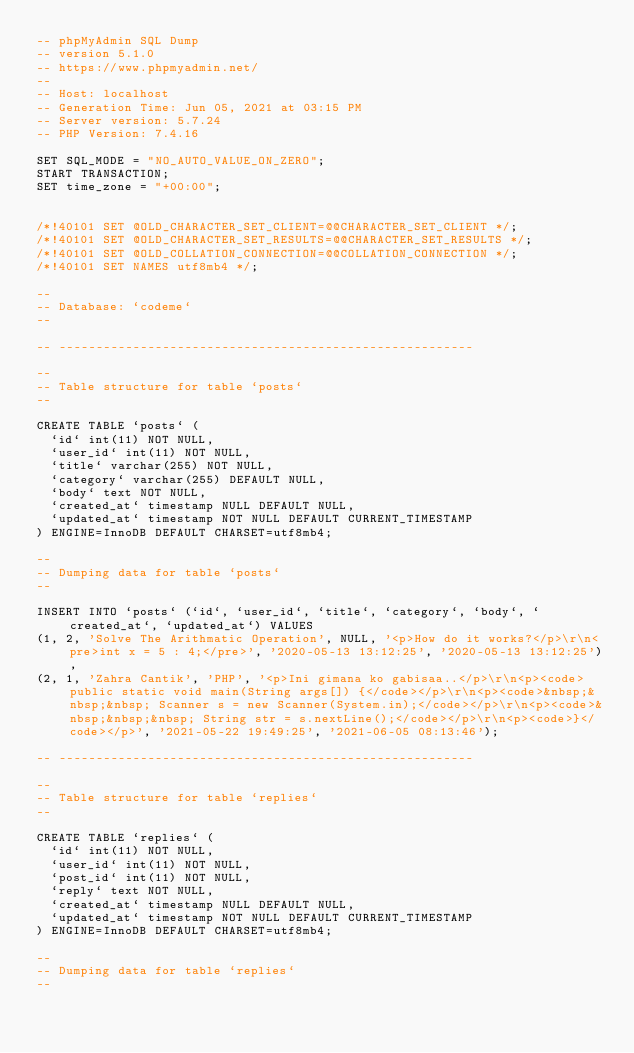<code> <loc_0><loc_0><loc_500><loc_500><_SQL_>-- phpMyAdmin SQL Dump
-- version 5.1.0
-- https://www.phpmyadmin.net/
--
-- Host: localhost
-- Generation Time: Jun 05, 2021 at 03:15 PM
-- Server version: 5.7.24
-- PHP Version: 7.4.16

SET SQL_MODE = "NO_AUTO_VALUE_ON_ZERO";
START TRANSACTION;
SET time_zone = "+00:00";


/*!40101 SET @OLD_CHARACTER_SET_CLIENT=@@CHARACTER_SET_CLIENT */;
/*!40101 SET @OLD_CHARACTER_SET_RESULTS=@@CHARACTER_SET_RESULTS */;
/*!40101 SET @OLD_COLLATION_CONNECTION=@@COLLATION_CONNECTION */;
/*!40101 SET NAMES utf8mb4 */;

--
-- Database: `codeme`
--

-- --------------------------------------------------------

--
-- Table structure for table `posts`
--

CREATE TABLE `posts` (
  `id` int(11) NOT NULL,
  `user_id` int(11) NOT NULL,
  `title` varchar(255) NOT NULL,
  `category` varchar(255) DEFAULT NULL,
  `body` text NOT NULL,
  `created_at` timestamp NULL DEFAULT NULL,
  `updated_at` timestamp NOT NULL DEFAULT CURRENT_TIMESTAMP
) ENGINE=InnoDB DEFAULT CHARSET=utf8mb4;

--
-- Dumping data for table `posts`
--

INSERT INTO `posts` (`id`, `user_id`, `title`, `category`, `body`, `created_at`, `updated_at`) VALUES
(1, 2, 'Solve The Arithmatic Operation', NULL, '<p>How do it works?</p>\r\n<pre>int x = 5 : 4;</pre>', '2020-05-13 13:12:25', '2020-05-13 13:12:25'),
(2, 1, 'Zahra Cantik', 'PHP', '<p>Ini gimana ko gabisaa..</p>\r\n<p><code>public static void main(String args[]) {</code></p>\r\n<p><code>&nbsp;&nbsp;&nbsp; Scanner s = new Scanner(System.in);</code></p>\r\n<p><code>&nbsp;&nbsp;&nbsp; String str = s.nextLine();</code></p>\r\n<p><code>}</code></p>', '2021-05-22 19:49:25', '2021-06-05 08:13:46');

-- --------------------------------------------------------

--
-- Table structure for table `replies`
--

CREATE TABLE `replies` (
  `id` int(11) NOT NULL,
  `user_id` int(11) NOT NULL,
  `post_id` int(11) NOT NULL,
  `reply` text NOT NULL,
  `created_at` timestamp NULL DEFAULT NULL,
  `updated_at` timestamp NOT NULL DEFAULT CURRENT_TIMESTAMP
) ENGINE=InnoDB DEFAULT CHARSET=utf8mb4;

--
-- Dumping data for table `replies`
--
</code> 